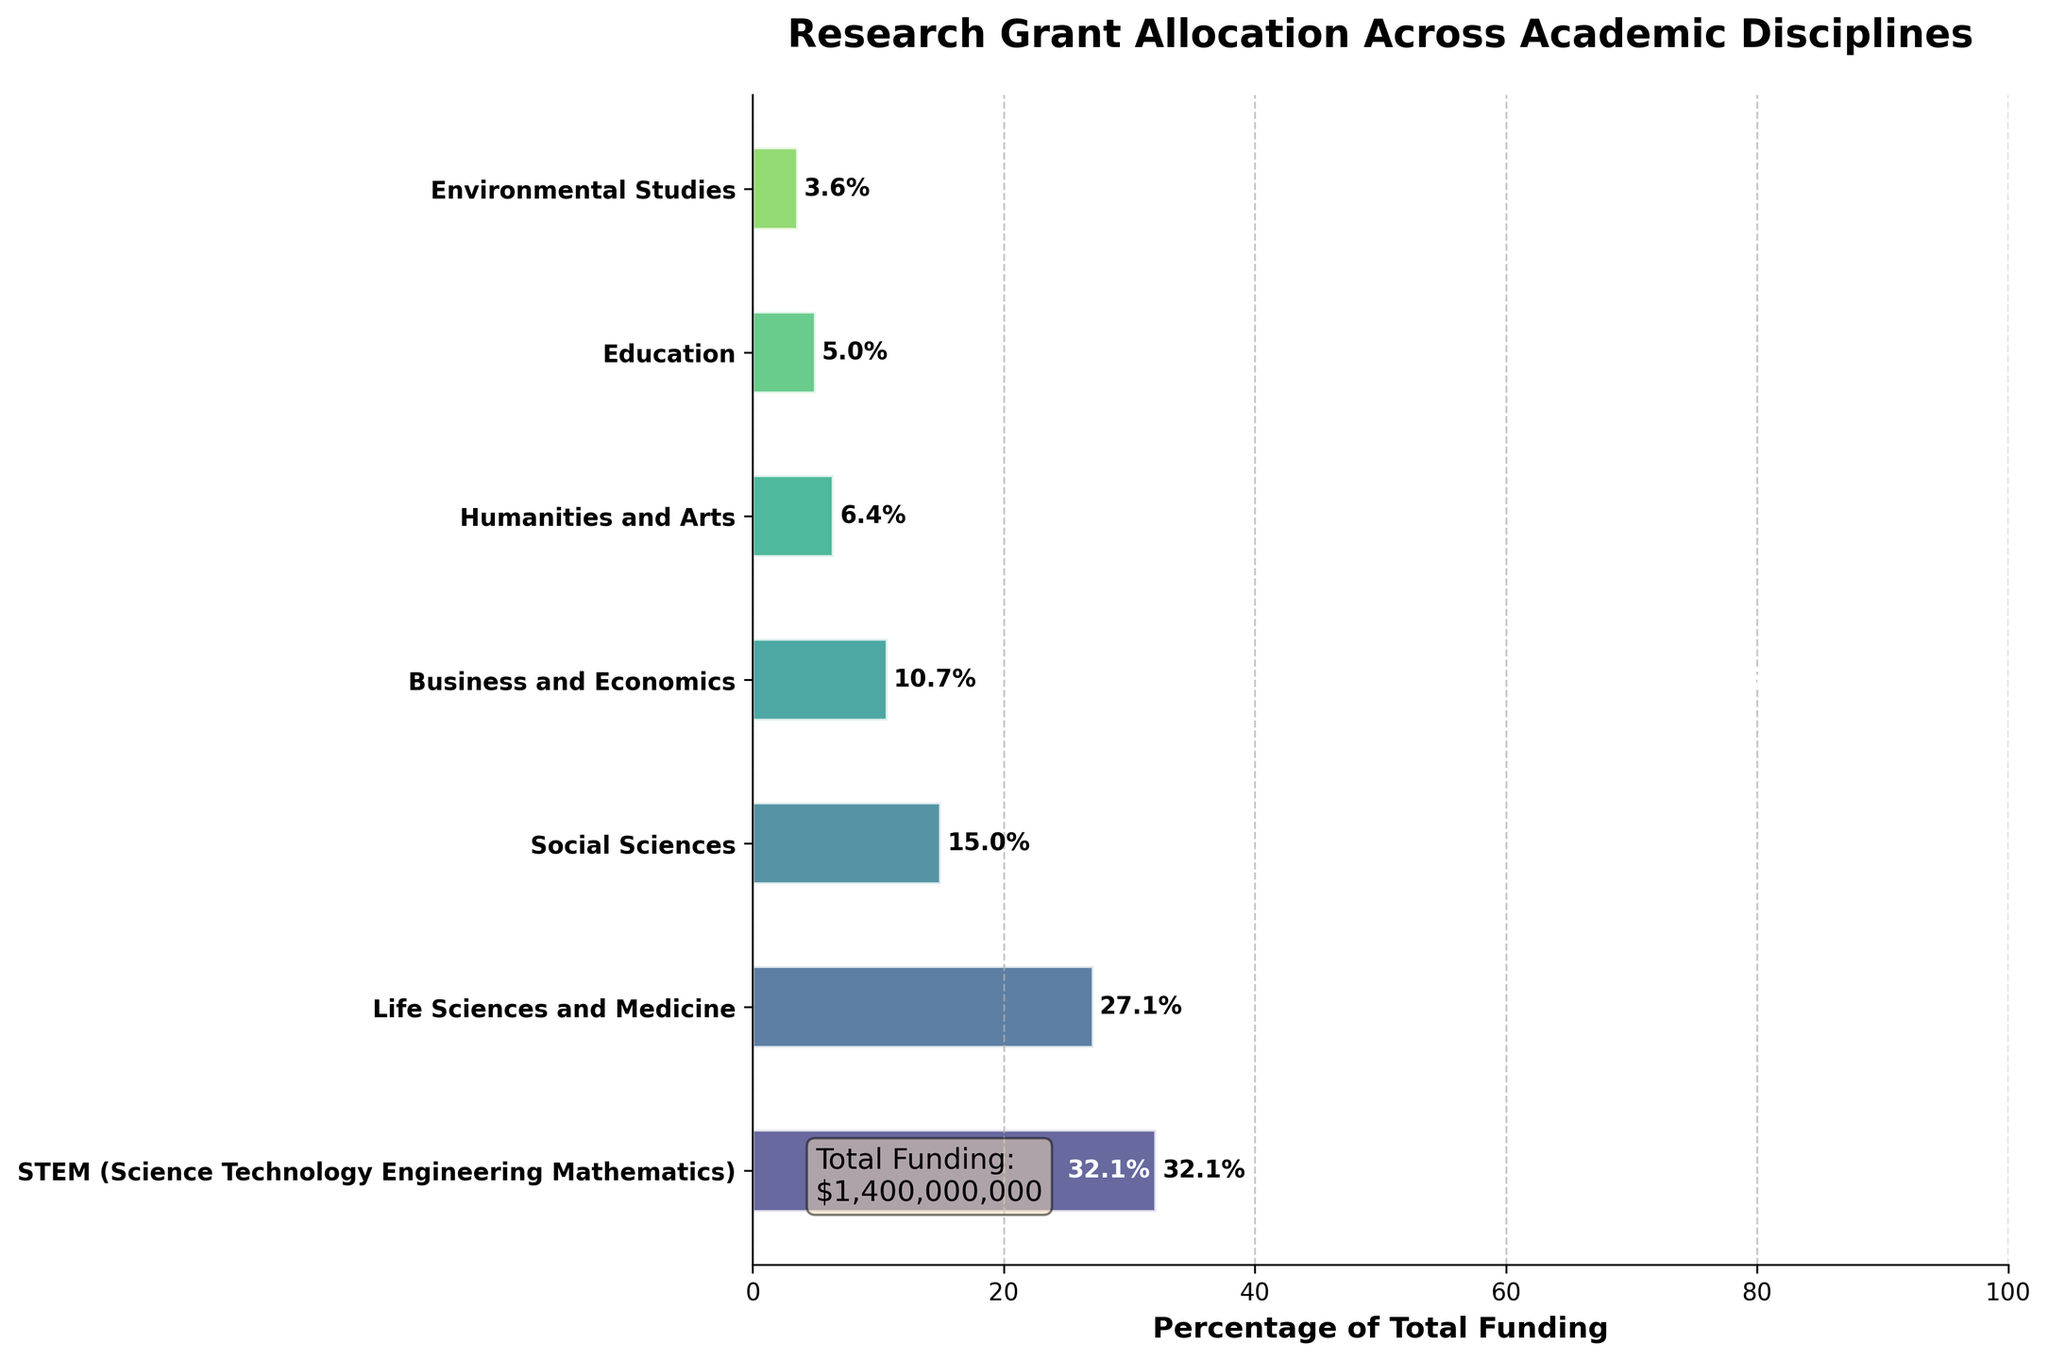What is the title of the figure? The title of the figure is written at the top of the chart in bold font. It summarizes what the chart is about.
Answer: Research Grant Allocation Across Academic Disciplines Which discipline received the highest amount of funding? The discipline with the highest funding is displayed at the top of the funnel chart.
Answer: STEM (Science Technology Engineering Mathematics) What percentage of the total funding does the STEM discipline receive? The percentages provided in the horizontal bars show the proportion of total funding each discipline receives. The STEM discipline has a percentage label next to its bar.
Answer: 39.6% What is the cumulative funding percentage for Life Sciences and Medicine by itself? The cumulative percentage is shown at the end of the horizontal bar for Life Sciences and Medicine, indicating the sum of the funding percentages up to that discipline.
Answer: 72.0% How many academic disciplines are listed in the figure? Count the number of horizontal bars representing different academic disciplines in the funnel chart.
Answer: 7 What is the difference in funding percentage between Business and Economics and Education? Subtract the funding percentage of Education from that of Business and Economics. Business and Economics has 13.2% and Education has 6.2%. 13.2% - 6.2% = 7%
Answer: 7% What is the total funding amount represented in the figure? The total funding amount is displayed in a text box within the figure, typically towards the bottom or corner.
Answer: $1,400,000,000 Which discipline has a higher cumulative percentage: Social Sciences or Business and Economics? Compare the cumulative percentages at the end of the horizontal bars for Social Sciences and Business and Economics. Social Sciences: 87.0%, Business and Economics: 98.1%
Answer: Business and Economics What is the percentage of total funding for Humanities and Arts? Look at the percentage label next to the horizontal bar for Humanities and Arts.
Answer: 6.4% What is the cumulative funding percentage up to and including Social Sciences? The cumulative percentage at the end of the horizontal bar for Social Sciences indicates the total funding percentage up to and including this discipline.
Answer: 87.0% 